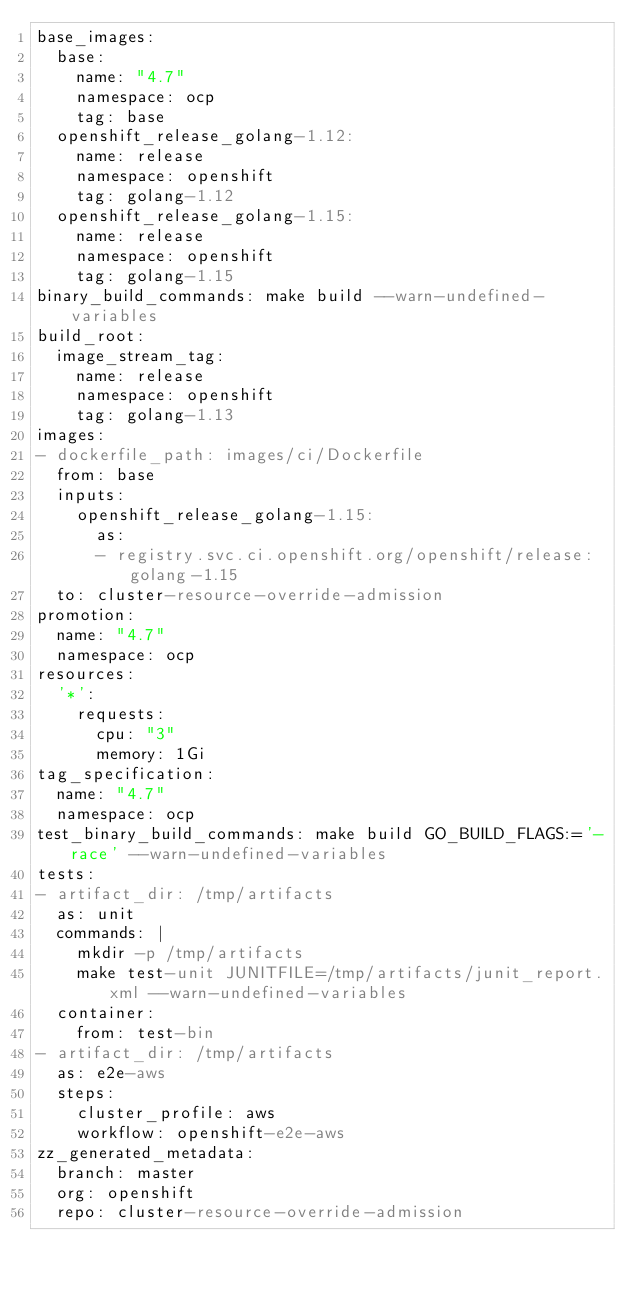<code> <loc_0><loc_0><loc_500><loc_500><_YAML_>base_images:
  base:
    name: "4.7"
    namespace: ocp
    tag: base
  openshift_release_golang-1.12:
    name: release
    namespace: openshift
    tag: golang-1.12
  openshift_release_golang-1.15:
    name: release
    namespace: openshift
    tag: golang-1.15
binary_build_commands: make build --warn-undefined-variables
build_root:
  image_stream_tag:
    name: release
    namespace: openshift
    tag: golang-1.13
images:
- dockerfile_path: images/ci/Dockerfile
  from: base
  inputs:
    openshift_release_golang-1.15:
      as:
      - registry.svc.ci.openshift.org/openshift/release:golang-1.15
  to: cluster-resource-override-admission
promotion:
  name: "4.7"
  namespace: ocp
resources:
  '*':
    requests:
      cpu: "3"
      memory: 1Gi
tag_specification:
  name: "4.7"
  namespace: ocp
test_binary_build_commands: make build GO_BUILD_FLAGS:='-race' --warn-undefined-variables
tests:
- artifact_dir: /tmp/artifacts
  as: unit
  commands: |
    mkdir -p /tmp/artifacts
    make test-unit JUNITFILE=/tmp/artifacts/junit_report.xml --warn-undefined-variables
  container:
    from: test-bin
- artifact_dir: /tmp/artifacts
  as: e2e-aws
  steps:
    cluster_profile: aws
    workflow: openshift-e2e-aws
zz_generated_metadata:
  branch: master
  org: openshift
  repo: cluster-resource-override-admission
</code> 